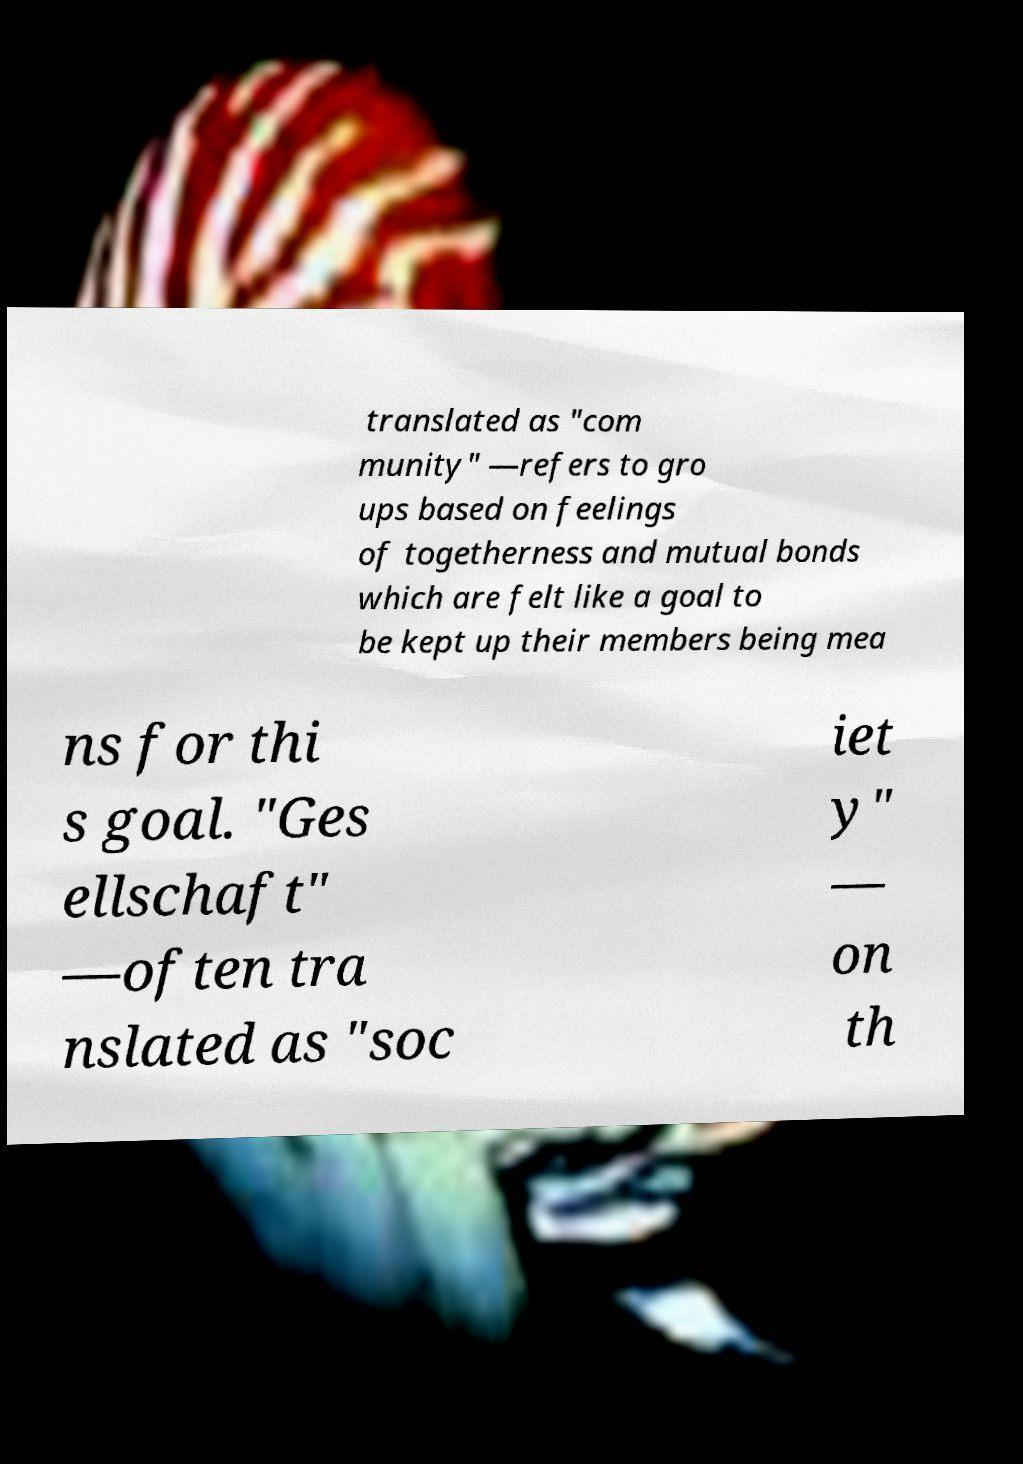Could you extract and type out the text from this image? translated as "com munity" —refers to gro ups based on feelings of togetherness and mutual bonds which are felt like a goal to be kept up their members being mea ns for thi s goal. "Ges ellschaft" —often tra nslated as "soc iet y" — on th 